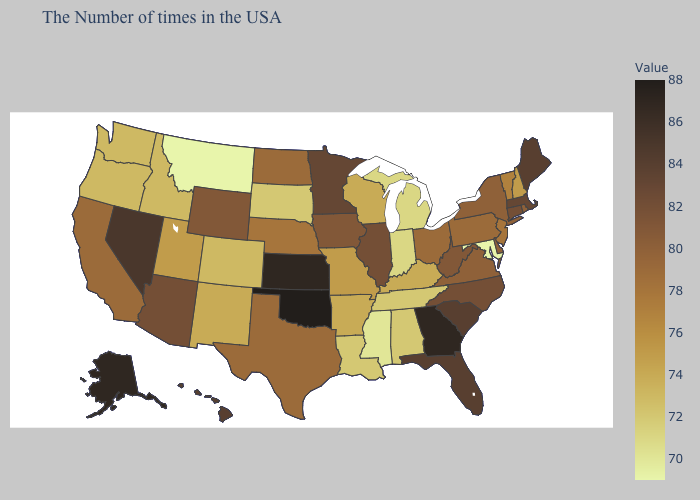Which states have the lowest value in the USA?
Concise answer only. Maryland, Montana. Does Maryland have the lowest value in the USA?
Concise answer only. Yes. Is the legend a continuous bar?
Keep it brief. Yes. Which states have the lowest value in the USA?
Keep it brief. Maryland, Montana. Which states have the lowest value in the Northeast?
Be succinct. New Hampshire. Among the states that border California , does Oregon have the lowest value?
Keep it brief. Yes. Does Kansas have the highest value in the MidWest?
Keep it brief. Yes. 